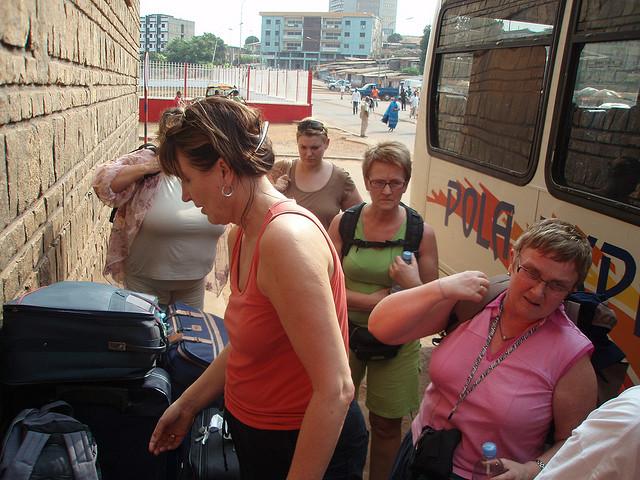What are the women in the process of doing?
Be succinct. Getting their luggage. What vehicle are the women standing next to?
Quick response, please. Bus. Which woman has a pink top?
Give a very brief answer. Right. 